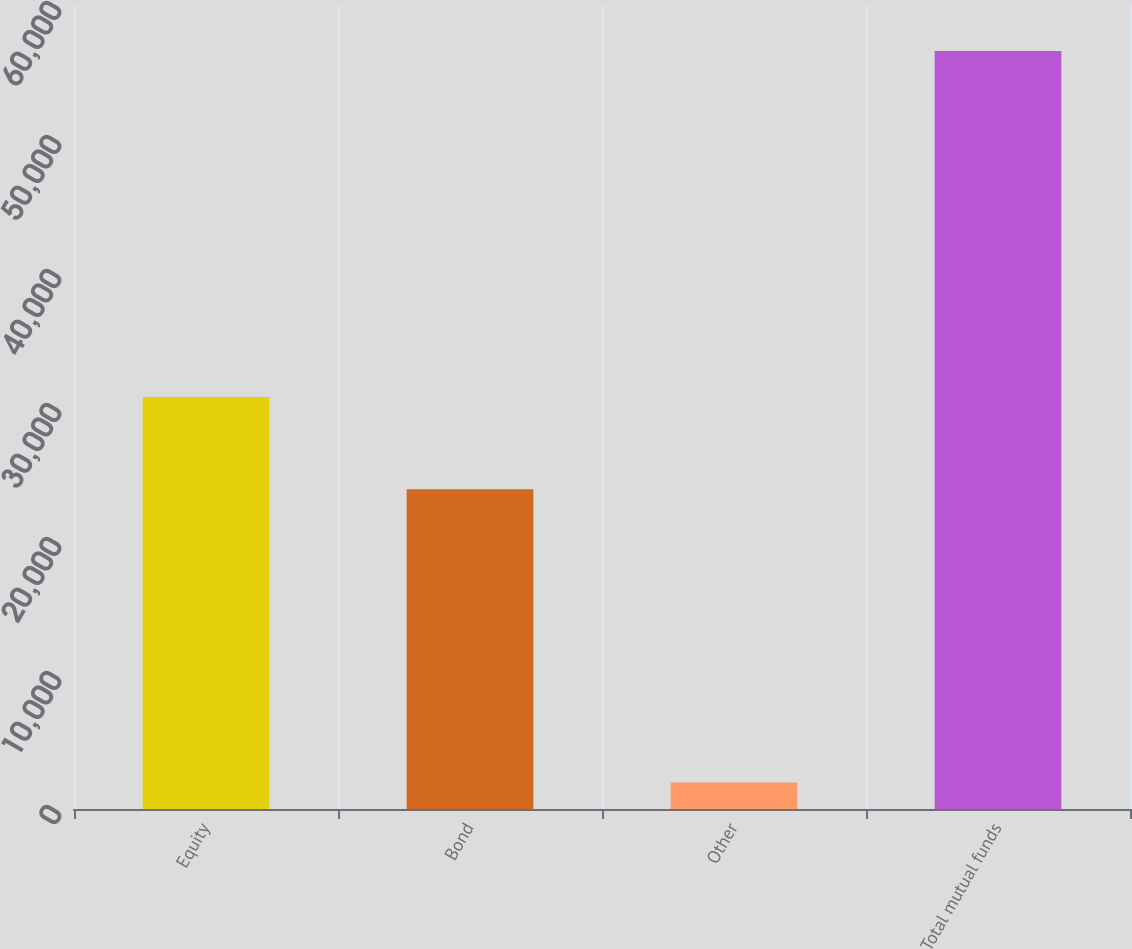Convert chart. <chart><loc_0><loc_0><loc_500><loc_500><bar_chart><fcel>Equity<fcel>Bond<fcel>Other<fcel>Total mutual funds<nl><fcel>30738<fcel>23862<fcel>1969<fcel>56569<nl></chart> 